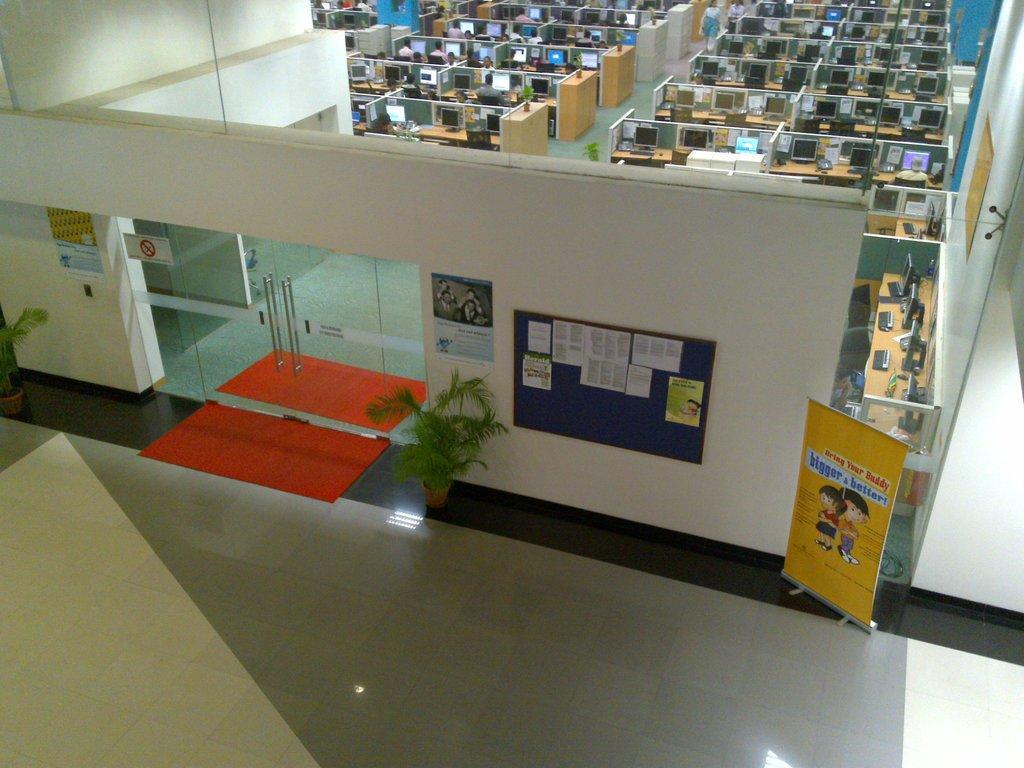Can you describe this image briefly? There is a wall with notice board, posters and glass doors. Near to that there is a carpet, pots with plants and banner. On the notice board there are notices. In the back there are many tables with monitors. Also there are pots with plants. 